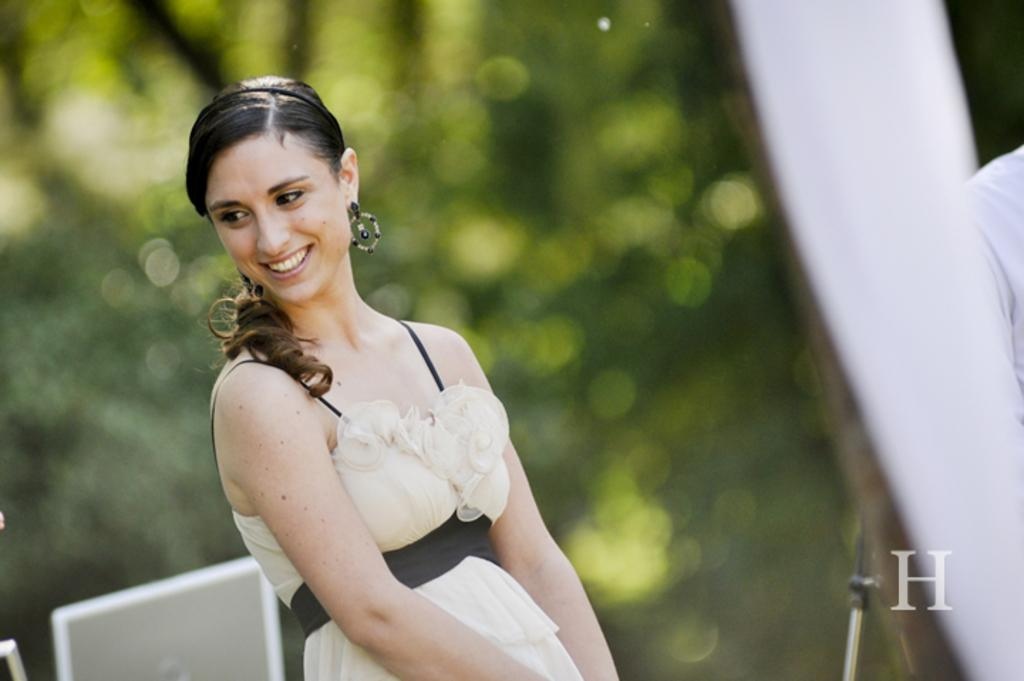What can be seen in the image? There is a person in the image. Can you describe the person's appearance? The person is wearing clothes. What is present in the bottom right corner of the image? There is an alphabet in the bottom right of the image. How would you describe the background of the image? The background of the image is blurred. What type of glue is being used to attach the pocket to the board in the image? There is no pocket or board present in the image, and therefore no glue or attachment process can be observed. 